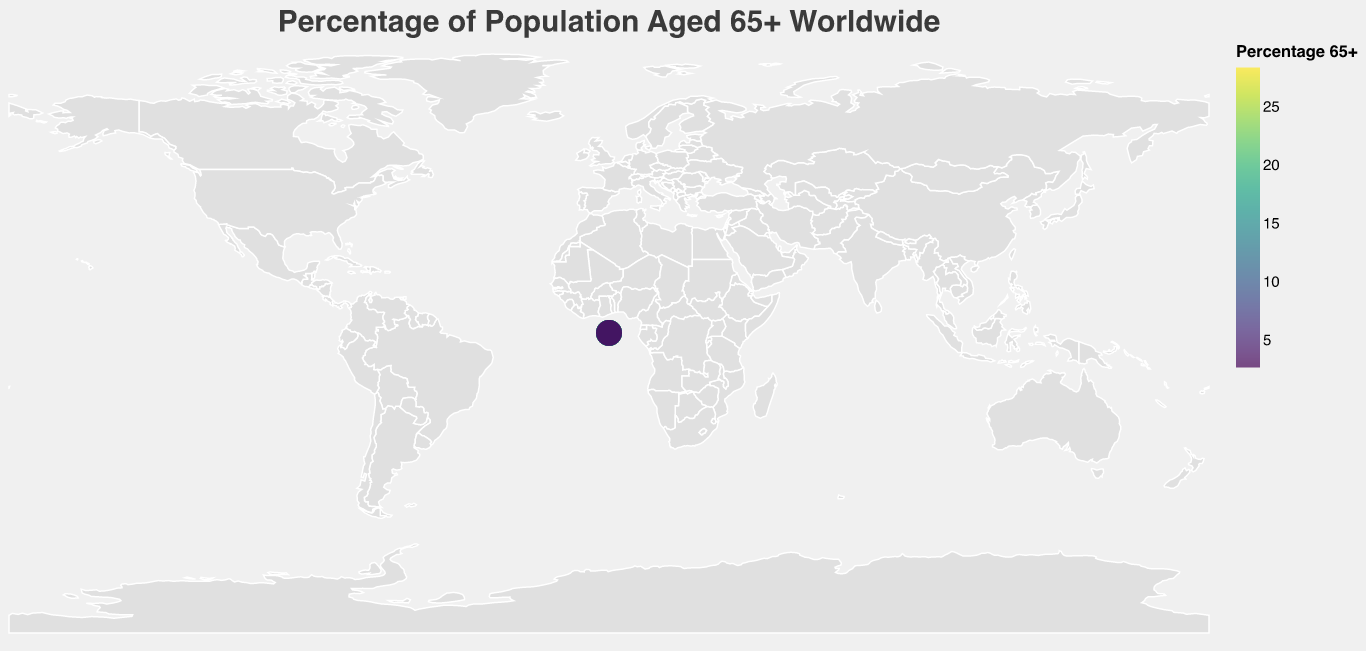Which country has the highest percentage of the population aged 65+? The figure shows different countries with corresponding circles indicating the percentage of the population aged 65+. The country with the largest value should have the most intense color in the color scale (viridis) and a value of 28.4 when hovering over it.
Answer: Japan Which country has the lowest percentage of the population aged 65+? By referring to the circles and their colors indicating the percentage of the population aged 65+, the country with the smallest value of 2.7 is the least intense on the color scale (viridis).
Answer: Nigeria What is the average percentage of the population aged 65+ among the listed European countries? Identify the European countries (Italy, Finland, Portugal, Greece, Germany, Sweden, France, United Kingdom) and calculate their average: (23.2 + 22.6 + 22.4 + 22.3 + 21.7 + 20.3 + 20.1 + 18.7) / 8 = 171.3 / 8
Answer: 21.4 Which countries have a percentage of the population aged 65+ greater than 20%? Identify the countries with values above 20% from the color-coded circles. These countries are Japan, Italy, Finland, Portugal, Greece, Germany, Sweden, and France.
Answer: Japan, Italy, Finland, Portugal, Greece, Germany, Sweden, France By how much does the percentage of the population aged 65+ in Canada differ from that in the United States? Subtract the percentage for the United States from that of Canada: 18.0 - 16.9 = 1.1
Answer: 1.1 What is the color scheme used to represent the percentage values? The figure uses the viridis color scale, which transitions from yellow to green to blue, to represent different percentages. Higher percentages are indicated by more yellowish hues.
Answer: Viridis How does the percentage of the population aged 65+ in China compare to that in the United States? The percentage in the United States is 16.9%, while in China it is 12.0%. The value in the United States is higher.
Answer: United States has a higher percentage 